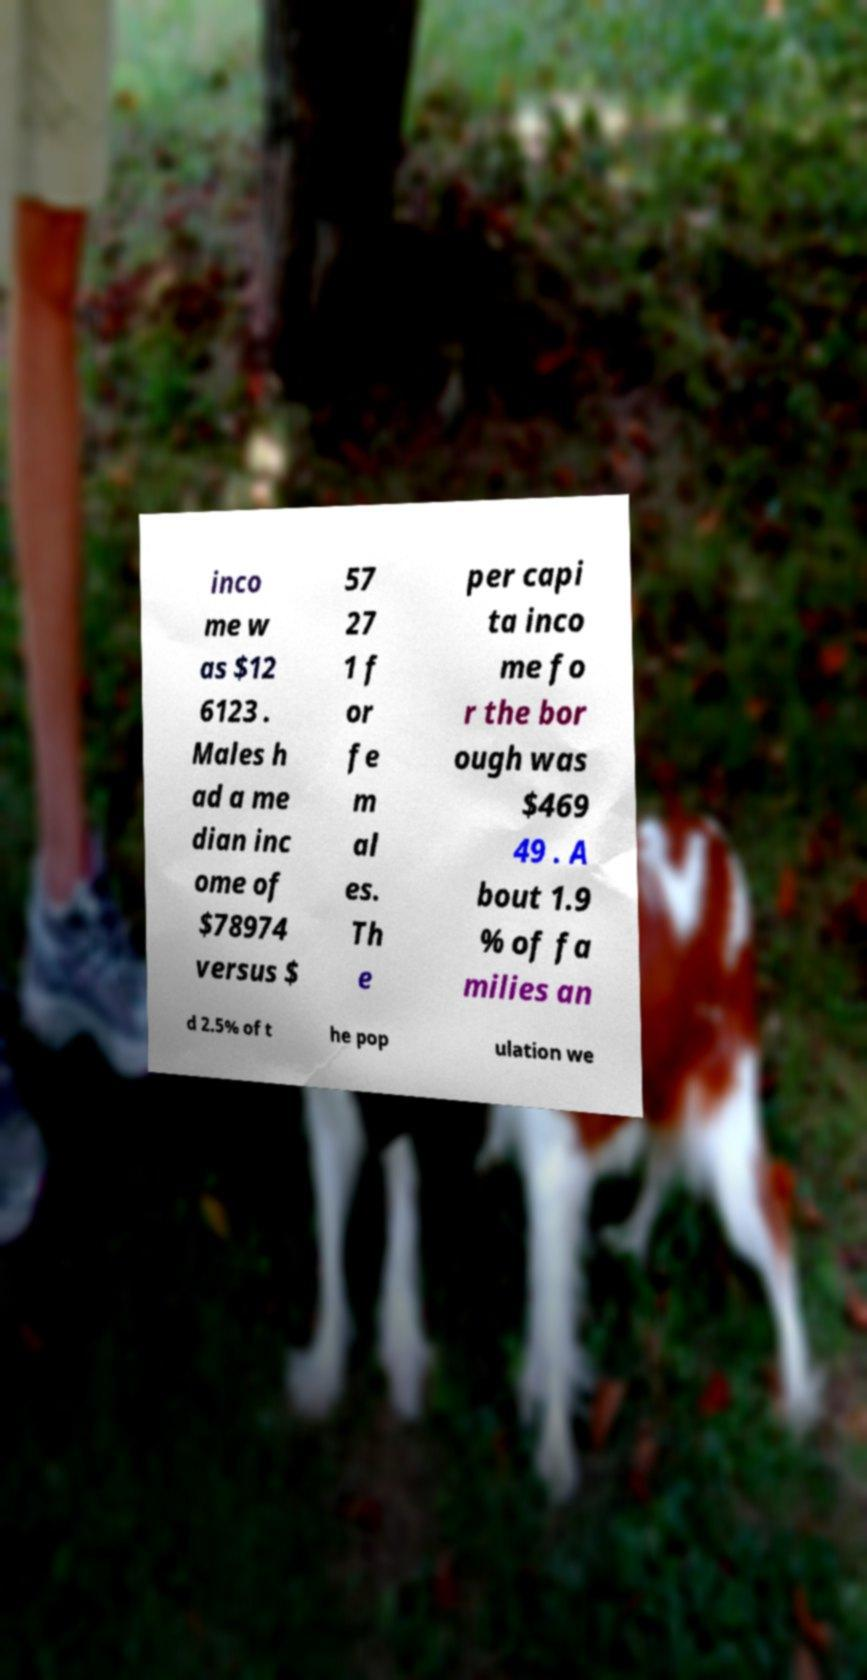Could you extract and type out the text from this image? inco me w as $12 6123 . Males h ad a me dian inc ome of $78974 versus $ 57 27 1 f or fe m al es. Th e per capi ta inco me fo r the bor ough was $469 49 . A bout 1.9 % of fa milies an d 2.5% of t he pop ulation we 